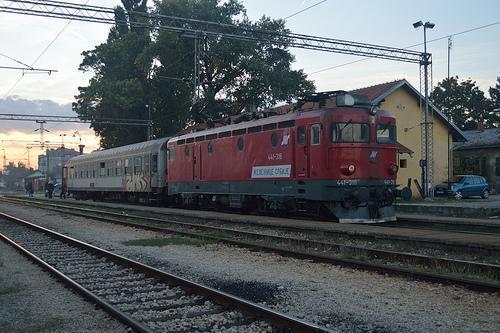How many train cars are shown?
Give a very brief answer. 2. How many trains are shown?
Give a very brief answer. 1. 